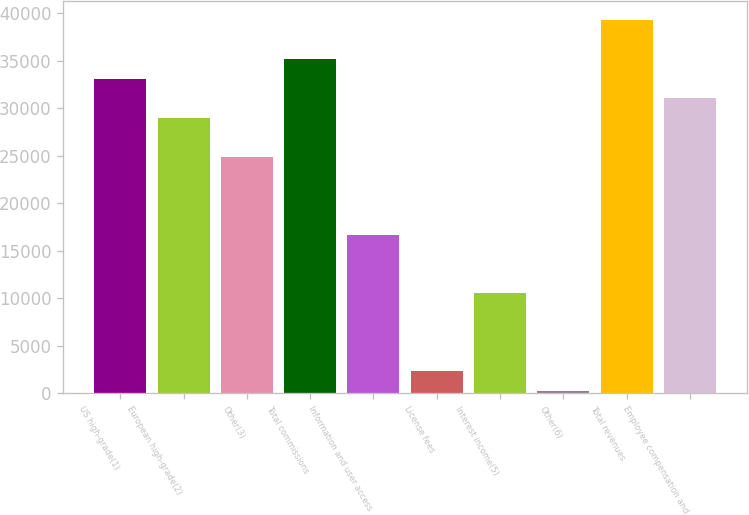Convert chart. <chart><loc_0><loc_0><loc_500><loc_500><bar_chart><fcel>US high-grade(1)<fcel>European high-grade(2)<fcel>Other(3)<fcel>Total commissions<fcel>Information and user access<fcel>License fees<fcel>Interest income(5)<fcel>Other(6)<fcel>Total revenues<fcel>Employee compensation and<nl><fcel>33095.6<fcel>28988.4<fcel>24881.2<fcel>35149.2<fcel>16666.8<fcel>2291.6<fcel>10506<fcel>238<fcel>39256.4<fcel>31042<nl></chart> 